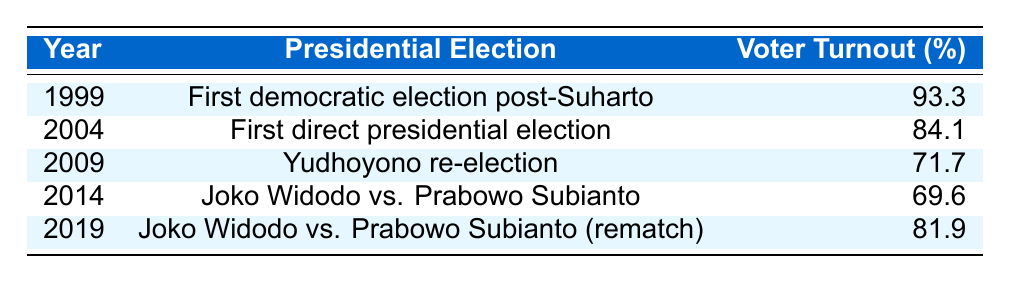What was the voter turnout percentage in the 2009 presidential election? The table shows the row for the year 2009, which states that the voter turnout percentage for that election was 71.7%.
Answer: 71.7% Which presidential election had the highest voter turnout percentage? By examining the table, we can see that the year 1999 has the highest voter turnout percentage at 93.3%.
Answer: 1999 What is the average voter turnout percentage across all the years listed? We add the voter turnouts: 93.3 + 84.1 + 71.7 + 69.6 + 81.9 = 400.6. There are 5 elections, so the average is 400.6 / 5 = 80.12%.
Answer: 80.12% Did the voter turnout percentage decrease from 2004 to 2009? The table shows that in 2004 the turnout was 84.1% and in 2009 it was 71.7%, indicating a decrease.
Answer: Yes What was the difference in voter turnout between the elections held in 2004 and 2014? From the table, we see that the voter turnout for 2004 was 84.1% and for 2014 it was 69.6%. The difference is 84.1 - 69.6 = 14.5%.
Answer: 14.5% Which election had a voter turnout less than 70%? In the table, both the 2009 election (71.7%) and the 2014 election (69.6%) are below 70%; only the 2014 election is below this threshold.
Answer: 2014 Was the voter turnout higher in the second election between Joko Widodo and Prabowo Subianto than in the first? The first election (2014) had a turnout of 69.6%, while the rematch in 2019 had 81.9%, showing that the turnout in 2019 was indeed higher.
Answer: Yes How many elections had a voter turnout percentage above 80%? Looking at the table, only two elections had a turnout above 80%: 1999 (93.3%) and 2004 (84.1%).
Answer: 2 What was the trend in voter turnout from 1999 to 2014? The turnout decreased from 93.3% in 1999 to 69.6% in 2014, indicating a downward trend over these years.
Answer: Decreasing trend What was the voter turnout in the 2019 election, and how does it compare to the 2009 election? The 2019 election had a voter turnout of 81.9%, which is higher than the 2009 election turnout of 71.7%, showing an improvement.
Answer: Higher than 2009 